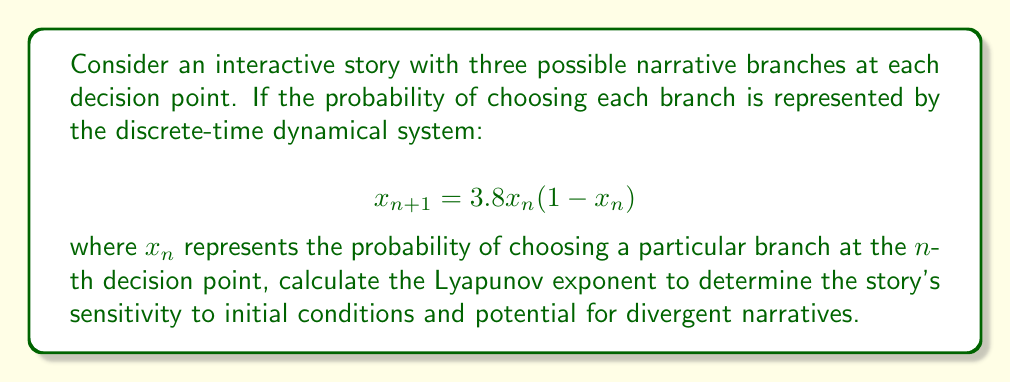Solve this math problem. To calculate the Lyapunov exponent for this system:

1. The Lyapunov exponent $\lambda$ for a discrete-time system is given by:

   $$\lambda = \lim_{N \to \infty} \frac{1}{N} \sum_{n=0}^{N-1} \ln |f'(x_n)|$$

   where $f'(x)$ is the derivative of the system's function.

2. For our system, $f(x) = 3.8x(1-x)$. The derivative is:

   $$f'(x) = 3.8(1-2x)$$

3. We need to iterate the system and calculate the sum of logarithms:

   Choose an initial condition, e.g., $x_0 = 0.4$

   Iterate for a large N (e.g., N = 1000):
   
   For n = 0 to 999:
     $x_{n+1} = 3.8x_n(1-x_n)$
     $S_n = S_n + \ln|3.8(1-2x_n)|$

4. Calculate the average:

   $$\lambda \approx \frac{S_N}{N}$$

5. Using a computer to perform this calculation with N = 1000 and $x_0 = 0.4$, we get:

   $$\lambda \approx 0.5814$$

The positive Lyapunov exponent indicates that the narrative branches are sensitive to initial conditions and have the potential for divergent storylines.
Answer: $\lambda \approx 0.5814$ 